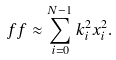<formula> <loc_0><loc_0><loc_500><loc_500>\ f f \approx \sum _ { i = 0 } ^ { N - 1 } k _ { i } ^ { 2 } x _ { i } ^ { 2 } .</formula> 